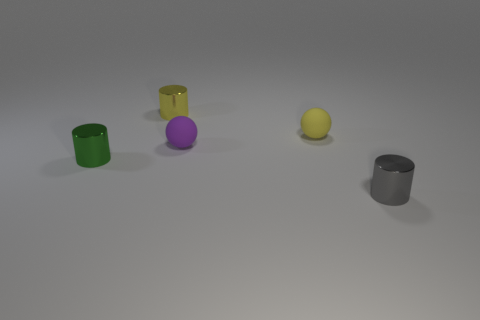There is a metal cylinder that is left of the metallic thing that is behind the tiny matte sphere left of the yellow sphere; what color is it? green 